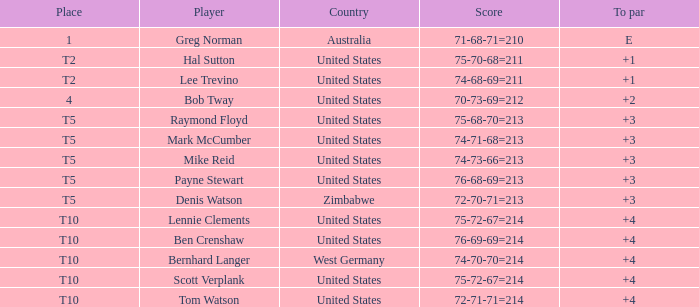Parse the table in full. {'header': ['Place', 'Player', 'Country', 'Score', 'To par'], 'rows': [['1', 'Greg Norman', 'Australia', '71-68-71=210', 'E'], ['T2', 'Hal Sutton', 'United States', '75-70-68=211', '+1'], ['T2', 'Lee Trevino', 'United States', '74-68-69=211', '+1'], ['4', 'Bob Tway', 'United States', '70-73-69=212', '+2'], ['T5', 'Raymond Floyd', 'United States', '75-68-70=213', '+3'], ['T5', 'Mark McCumber', 'United States', '74-71-68=213', '+3'], ['T5', 'Mike Reid', 'United States', '74-73-66=213', '+3'], ['T5', 'Payne Stewart', 'United States', '76-68-69=213', '+3'], ['T5', 'Denis Watson', 'Zimbabwe', '72-70-71=213', '+3'], ['T10', 'Lennie Clements', 'United States', '75-72-67=214', '+4'], ['T10', 'Ben Crenshaw', 'United States', '76-69-69=214', '+4'], ['T10', 'Bernhard Langer', 'West Germany', '74-70-70=214', '+4'], ['T10', 'Scott Verplank', 'United States', '75-72-67=214', '+4'], ['T10', 'Tom Watson', 'United States', '72-71-71=214', '+4']]} What is player raymond floyd's country? United States. 